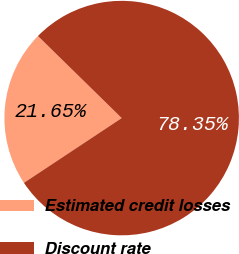Convert chart. <chart><loc_0><loc_0><loc_500><loc_500><pie_chart><fcel>Estimated credit losses<fcel>Discount rate<nl><fcel>21.65%<fcel>78.35%<nl></chart> 